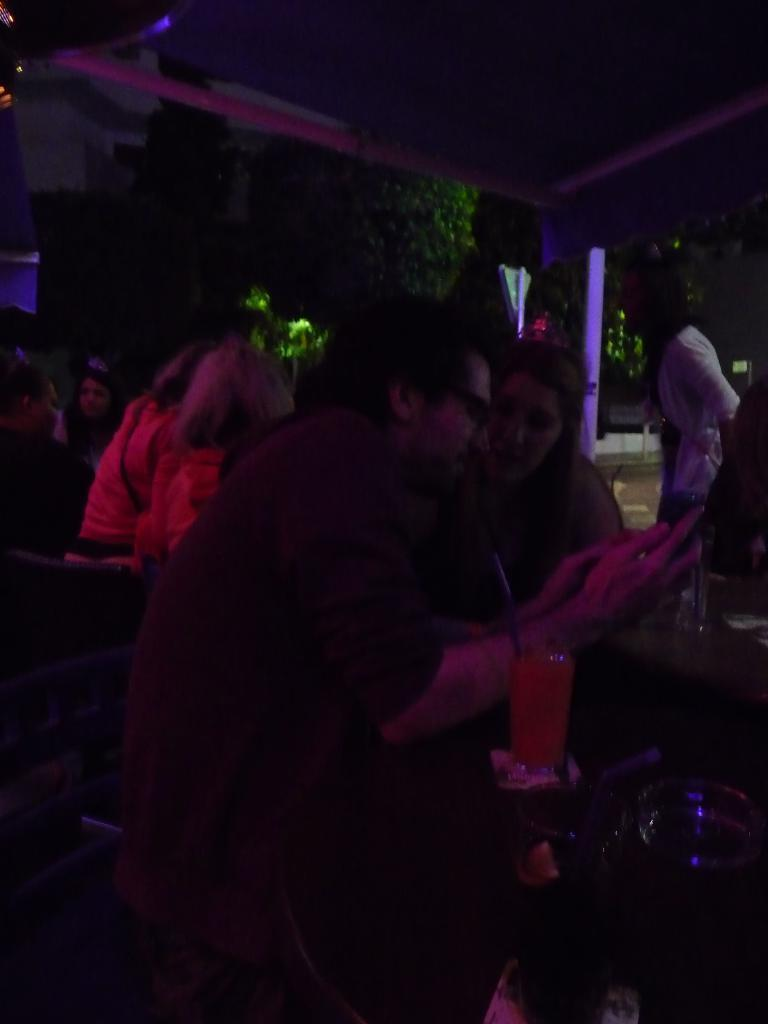What is happening in the image? There are people standing in the image. Can you describe any objects in the image? There is a glass on a table in the image. What type of machine is being used by the people in the image? There is no machine present in the image; it only shows people standing and a glass on a table. 